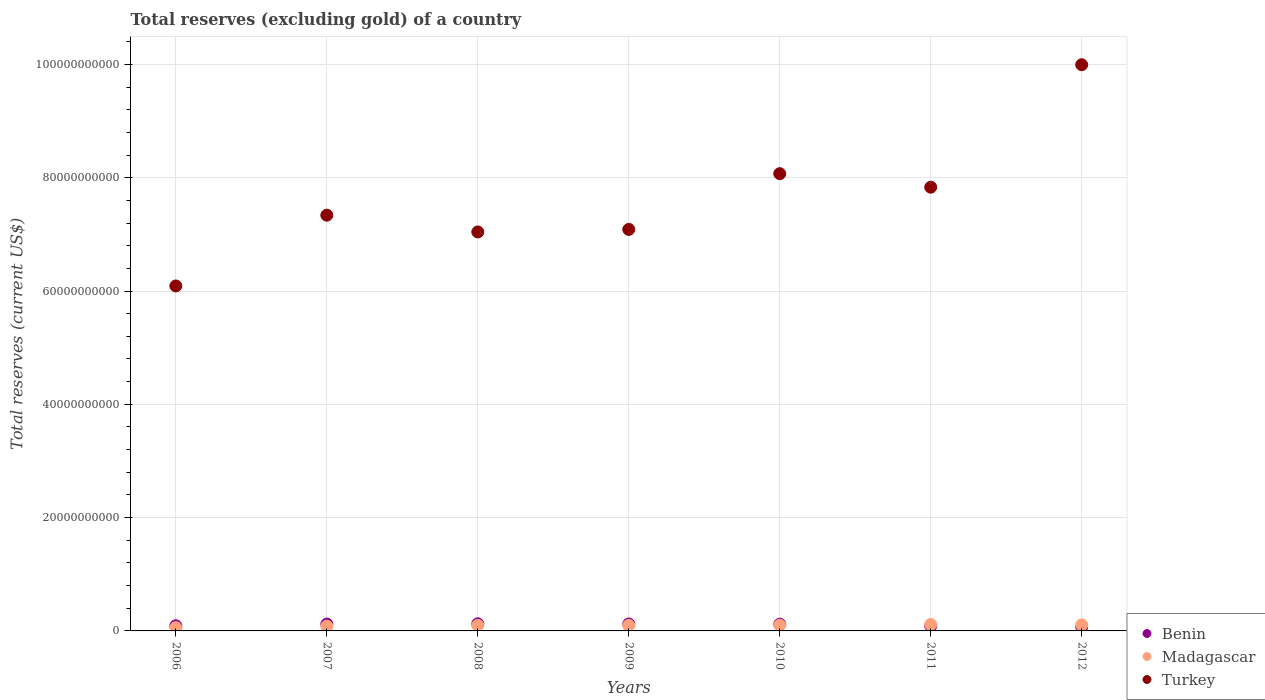How many different coloured dotlines are there?
Offer a terse response. 3. Is the number of dotlines equal to the number of legend labels?
Offer a very short reply. Yes. What is the total reserves (excluding gold) in Benin in 2006?
Provide a succinct answer. 9.12e+08. Across all years, what is the maximum total reserves (excluding gold) in Madagascar?
Ensure brevity in your answer.  1.13e+09. Across all years, what is the minimum total reserves (excluding gold) in Benin?
Offer a very short reply. 7.13e+08. In which year was the total reserves (excluding gold) in Benin maximum?
Ensure brevity in your answer.  2008. What is the total total reserves (excluding gold) in Turkey in the graph?
Provide a succinct answer. 5.35e+11. What is the difference between the total reserves (excluding gold) in Turkey in 2006 and that in 2011?
Ensure brevity in your answer.  -1.74e+1. What is the difference between the total reserves (excluding gold) in Benin in 2007 and the total reserves (excluding gold) in Turkey in 2010?
Offer a very short reply. -7.95e+1. What is the average total reserves (excluding gold) in Benin per year?
Offer a terse response. 1.06e+09. In the year 2012, what is the difference between the total reserves (excluding gold) in Madagascar and total reserves (excluding gold) in Benin?
Ensure brevity in your answer.  3.40e+08. What is the ratio of the total reserves (excluding gold) in Benin in 2007 to that in 2008?
Provide a short and direct response. 0.96. Is the total reserves (excluding gold) in Turkey in 2009 less than that in 2010?
Your response must be concise. Yes. What is the difference between the highest and the second highest total reserves (excluding gold) in Benin?
Give a very brief answer. 3.35e+07. What is the difference between the highest and the lowest total reserves (excluding gold) in Turkey?
Keep it short and to the point. 3.91e+1. In how many years, is the total reserves (excluding gold) in Turkey greater than the average total reserves (excluding gold) in Turkey taken over all years?
Your answer should be compact. 3. Is the sum of the total reserves (excluding gold) in Madagascar in 2011 and 2012 greater than the maximum total reserves (excluding gold) in Benin across all years?
Keep it short and to the point. Yes. Is it the case that in every year, the sum of the total reserves (excluding gold) in Benin and total reserves (excluding gold) in Madagascar  is greater than the total reserves (excluding gold) in Turkey?
Keep it short and to the point. No. Does the total reserves (excluding gold) in Madagascar monotonically increase over the years?
Provide a short and direct response. No. Is the total reserves (excluding gold) in Turkey strictly less than the total reserves (excluding gold) in Madagascar over the years?
Offer a terse response. No. How many dotlines are there?
Offer a terse response. 3. Does the graph contain any zero values?
Offer a very short reply. No. Does the graph contain grids?
Provide a short and direct response. Yes. How are the legend labels stacked?
Make the answer very short. Vertical. What is the title of the graph?
Keep it short and to the point. Total reserves (excluding gold) of a country. What is the label or title of the X-axis?
Provide a short and direct response. Years. What is the label or title of the Y-axis?
Your response must be concise. Total reserves (current US$). What is the Total reserves (current US$) of Benin in 2006?
Make the answer very short. 9.12e+08. What is the Total reserves (current US$) of Madagascar in 2006?
Provide a short and direct response. 5.83e+08. What is the Total reserves (current US$) in Turkey in 2006?
Provide a short and direct response. 6.09e+1. What is the Total reserves (current US$) of Benin in 2007?
Your answer should be very brief. 1.21e+09. What is the Total reserves (current US$) of Madagascar in 2007?
Keep it short and to the point. 8.47e+08. What is the Total reserves (current US$) in Turkey in 2007?
Your response must be concise. 7.34e+1. What is the Total reserves (current US$) of Benin in 2008?
Ensure brevity in your answer.  1.26e+09. What is the Total reserves (current US$) in Madagascar in 2008?
Your response must be concise. 9.82e+08. What is the Total reserves (current US$) in Turkey in 2008?
Your response must be concise. 7.04e+1. What is the Total reserves (current US$) of Benin in 2009?
Make the answer very short. 1.23e+09. What is the Total reserves (current US$) in Madagascar in 2009?
Offer a terse response. 9.82e+08. What is the Total reserves (current US$) of Turkey in 2009?
Provide a short and direct response. 7.09e+1. What is the Total reserves (current US$) in Benin in 2010?
Offer a terse response. 1.20e+09. What is the Total reserves (current US$) in Madagascar in 2010?
Your response must be concise. 1.02e+09. What is the Total reserves (current US$) in Turkey in 2010?
Your response must be concise. 8.07e+1. What is the Total reserves (current US$) of Benin in 2011?
Your response must be concise. 8.87e+08. What is the Total reserves (current US$) in Madagascar in 2011?
Your answer should be very brief. 1.13e+09. What is the Total reserves (current US$) in Turkey in 2011?
Provide a short and direct response. 7.83e+1. What is the Total reserves (current US$) in Benin in 2012?
Provide a short and direct response. 7.13e+08. What is the Total reserves (current US$) in Madagascar in 2012?
Provide a short and direct response. 1.05e+09. What is the Total reserves (current US$) in Turkey in 2012?
Offer a very short reply. 9.99e+1. Across all years, what is the maximum Total reserves (current US$) in Benin?
Provide a succinct answer. 1.26e+09. Across all years, what is the maximum Total reserves (current US$) in Madagascar?
Give a very brief answer. 1.13e+09. Across all years, what is the maximum Total reserves (current US$) in Turkey?
Offer a terse response. 9.99e+1. Across all years, what is the minimum Total reserves (current US$) in Benin?
Your response must be concise. 7.13e+08. Across all years, what is the minimum Total reserves (current US$) in Madagascar?
Your answer should be very brief. 5.83e+08. Across all years, what is the minimum Total reserves (current US$) in Turkey?
Your answer should be very brief. 6.09e+1. What is the total Total reserves (current US$) of Benin in the graph?
Your answer should be very brief. 7.41e+09. What is the total Total reserves (current US$) of Madagascar in the graph?
Give a very brief answer. 6.60e+09. What is the total Total reserves (current US$) of Turkey in the graph?
Give a very brief answer. 5.35e+11. What is the difference between the Total reserves (current US$) of Benin in 2006 and that in 2007?
Your answer should be compact. -2.97e+08. What is the difference between the Total reserves (current US$) in Madagascar in 2006 and that in 2007?
Provide a succinct answer. -2.63e+08. What is the difference between the Total reserves (current US$) of Turkey in 2006 and that in 2007?
Make the answer very short. -1.25e+1. What is the difference between the Total reserves (current US$) of Benin in 2006 and that in 2008?
Offer a terse response. -3.51e+08. What is the difference between the Total reserves (current US$) of Madagascar in 2006 and that in 2008?
Ensure brevity in your answer.  -3.99e+08. What is the difference between the Total reserves (current US$) of Turkey in 2006 and that in 2008?
Offer a terse response. -9.54e+09. What is the difference between the Total reserves (current US$) of Benin in 2006 and that in 2009?
Provide a succinct answer. -3.18e+08. What is the difference between the Total reserves (current US$) in Madagascar in 2006 and that in 2009?
Ensure brevity in your answer.  -3.99e+08. What is the difference between the Total reserves (current US$) of Turkey in 2006 and that in 2009?
Your answer should be compact. -9.98e+09. What is the difference between the Total reserves (current US$) in Benin in 2006 and that in 2010?
Your response must be concise. -2.88e+08. What is the difference between the Total reserves (current US$) of Madagascar in 2006 and that in 2010?
Keep it short and to the point. -4.40e+08. What is the difference between the Total reserves (current US$) of Turkey in 2006 and that in 2010?
Give a very brief answer. -1.98e+1. What is the difference between the Total reserves (current US$) in Benin in 2006 and that in 2011?
Your answer should be very brief. 2.48e+07. What is the difference between the Total reserves (current US$) in Madagascar in 2006 and that in 2011?
Your answer should be very brief. -5.51e+08. What is the difference between the Total reserves (current US$) of Turkey in 2006 and that in 2011?
Provide a succinct answer. -1.74e+1. What is the difference between the Total reserves (current US$) in Benin in 2006 and that in 2012?
Offer a very short reply. 1.99e+08. What is the difference between the Total reserves (current US$) of Madagascar in 2006 and that in 2012?
Your answer should be compact. -4.70e+08. What is the difference between the Total reserves (current US$) of Turkey in 2006 and that in 2012?
Ensure brevity in your answer.  -3.91e+1. What is the difference between the Total reserves (current US$) in Benin in 2007 and that in 2008?
Your answer should be very brief. -5.41e+07. What is the difference between the Total reserves (current US$) of Madagascar in 2007 and that in 2008?
Your answer should be compact. -1.36e+08. What is the difference between the Total reserves (current US$) in Turkey in 2007 and that in 2008?
Your answer should be compact. 2.96e+09. What is the difference between the Total reserves (current US$) in Benin in 2007 and that in 2009?
Provide a short and direct response. -2.06e+07. What is the difference between the Total reserves (current US$) of Madagascar in 2007 and that in 2009?
Provide a short and direct response. -1.35e+08. What is the difference between the Total reserves (current US$) of Turkey in 2007 and that in 2009?
Provide a succinct answer. 2.51e+09. What is the difference between the Total reserves (current US$) of Benin in 2007 and that in 2010?
Give a very brief answer. 9.15e+06. What is the difference between the Total reserves (current US$) of Madagascar in 2007 and that in 2010?
Ensure brevity in your answer.  -1.76e+08. What is the difference between the Total reserves (current US$) of Turkey in 2007 and that in 2010?
Give a very brief answer. -7.33e+09. What is the difference between the Total reserves (current US$) in Benin in 2007 and that in 2011?
Give a very brief answer. 3.22e+08. What is the difference between the Total reserves (current US$) in Madagascar in 2007 and that in 2011?
Provide a succinct answer. -2.88e+08. What is the difference between the Total reserves (current US$) in Turkey in 2007 and that in 2011?
Ensure brevity in your answer.  -4.94e+09. What is the difference between the Total reserves (current US$) of Benin in 2007 and that in 2012?
Offer a very short reply. 4.96e+08. What is the difference between the Total reserves (current US$) of Madagascar in 2007 and that in 2012?
Give a very brief answer. -2.06e+08. What is the difference between the Total reserves (current US$) in Turkey in 2007 and that in 2012?
Ensure brevity in your answer.  -2.66e+1. What is the difference between the Total reserves (current US$) of Benin in 2008 and that in 2009?
Offer a terse response. 3.35e+07. What is the difference between the Total reserves (current US$) in Madagascar in 2008 and that in 2009?
Make the answer very short. 2.28e+05. What is the difference between the Total reserves (current US$) of Turkey in 2008 and that in 2009?
Offer a very short reply. -4.46e+08. What is the difference between the Total reserves (current US$) in Benin in 2008 and that in 2010?
Provide a succinct answer. 6.33e+07. What is the difference between the Total reserves (current US$) in Madagascar in 2008 and that in 2010?
Your response must be concise. -4.07e+07. What is the difference between the Total reserves (current US$) in Turkey in 2008 and that in 2010?
Make the answer very short. -1.03e+1. What is the difference between the Total reserves (current US$) in Benin in 2008 and that in 2011?
Keep it short and to the point. 3.76e+08. What is the difference between the Total reserves (current US$) of Madagascar in 2008 and that in 2011?
Your response must be concise. -1.52e+08. What is the difference between the Total reserves (current US$) of Turkey in 2008 and that in 2011?
Give a very brief answer. -7.89e+09. What is the difference between the Total reserves (current US$) of Benin in 2008 and that in 2012?
Keep it short and to the point. 5.51e+08. What is the difference between the Total reserves (current US$) in Madagascar in 2008 and that in 2012?
Provide a short and direct response. -7.05e+07. What is the difference between the Total reserves (current US$) of Turkey in 2008 and that in 2012?
Your answer should be compact. -2.95e+1. What is the difference between the Total reserves (current US$) in Benin in 2009 and that in 2010?
Offer a terse response. 2.98e+07. What is the difference between the Total reserves (current US$) of Madagascar in 2009 and that in 2010?
Give a very brief answer. -4.09e+07. What is the difference between the Total reserves (current US$) of Turkey in 2009 and that in 2010?
Make the answer very short. -9.84e+09. What is the difference between the Total reserves (current US$) of Benin in 2009 and that in 2011?
Your answer should be very brief. 3.42e+08. What is the difference between the Total reserves (current US$) of Madagascar in 2009 and that in 2011?
Provide a succinct answer. -1.52e+08. What is the difference between the Total reserves (current US$) of Turkey in 2009 and that in 2011?
Make the answer very short. -7.45e+09. What is the difference between the Total reserves (current US$) in Benin in 2009 and that in 2012?
Give a very brief answer. 5.17e+08. What is the difference between the Total reserves (current US$) in Madagascar in 2009 and that in 2012?
Your response must be concise. -7.07e+07. What is the difference between the Total reserves (current US$) in Turkey in 2009 and that in 2012?
Your answer should be very brief. -2.91e+1. What is the difference between the Total reserves (current US$) in Benin in 2010 and that in 2011?
Ensure brevity in your answer.  3.13e+08. What is the difference between the Total reserves (current US$) in Madagascar in 2010 and that in 2011?
Offer a very short reply. -1.12e+08. What is the difference between the Total reserves (current US$) in Turkey in 2010 and that in 2011?
Your response must be concise. 2.39e+09. What is the difference between the Total reserves (current US$) in Benin in 2010 and that in 2012?
Your answer should be very brief. 4.87e+08. What is the difference between the Total reserves (current US$) of Madagascar in 2010 and that in 2012?
Make the answer very short. -2.98e+07. What is the difference between the Total reserves (current US$) of Turkey in 2010 and that in 2012?
Make the answer very short. -1.92e+1. What is the difference between the Total reserves (current US$) of Benin in 2011 and that in 2012?
Your answer should be compact. 1.75e+08. What is the difference between the Total reserves (current US$) of Madagascar in 2011 and that in 2012?
Your answer should be compact. 8.17e+07. What is the difference between the Total reserves (current US$) in Turkey in 2011 and that in 2012?
Ensure brevity in your answer.  -2.16e+1. What is the difference between the Total reserves (current US$) of Benin in 2006 and the Total reserves (current US$) of Madagascar in 2007?
Your response must be concise. 6.55e+07. What is the difference between the Total reserves (current US$) of Benin in 2006 and the Total reserves (current US$) of Turkey in 2007?
Your response must be concise. -7.25e+1. What is the difference between the Total reserves (current US$) of Madagascar in 2006 and the Total reserves (current US$) of Turkey in 2007?
Ensure brevity in your answer.  -7.28e+1. What is the difference between the Total reserves (current US$) in Benin in 2006 and the Total reserves (current US$) in Madagascar in 2008?
Provide a succinct answer. -7.01e+07. What is the difference between the Total reserves (current US$) of Benin in 2006 and the Total reserves (current US$) of Turkey in 2008?
Offer a very short reply. -6.95e+1. What is the difference between the Total reserves (current US$) of Madagascar in 2006 and the Total reserves (current US$) of Turkey in 2008?
Your answer should be very brief. -6.98e+1. What is the difference between the Total reserves (current US$) in Benin in 2006 and the Total reserves (current US$) in Madagascar in 2009?
Your answer should be very brief. -6.99e+07. What is the difference between the Total reserves (current US$) in Benin in 2006 and the Total reserves (current US$) in Turkey in 2009?
Give a very brief answer. -7.00e+1. What is the difference between the Total reserves (current US$) of Madagascar in 2006 and the Total reserves (current US$) of Turkey in 2009?
Offer a very short reply. -7.03e+1. What is the difference between the Total reserves (current US$) of Benin in 2006 and the Total reserves (current US$) of Madagascar in 2010?
Keep it short and to the point. -1.11e+08. What is the difference between the Total reserves (current US$) of Benin in 2006 and the Total reserves (current US$) of Turkey in 2010?
Offer a terse response. -7.98e+1. What is the difference between the Total reserves (current US$) in Madagascar in 2006 and the Total reserves (current US$) in Turkey in 2010?
Offer a very short reply. -8.01e+1. What is the difference between the Total reserves (current US$) in Benin in 2006 and the Total reserves (current US$) in Madagascar in 2011?
Give a very brief answer. -2.22e+08. What is the difference between the Total reserves (current US$) in Benin in 2006 and the Total reserves (current US$) in Turkey in 2011?
Ensure brevity in your answer.  -7.74e+1. What is the difference between the Total reserves (current US$) in Madagascar in 2006 and the Total reserves (current US$) in Turkey in 2011?
Give a very brief answer. -7.77e+1. What is the difference between the Total reserves (current US$) in Benin in 2006 and the Total reserves (current US$) in Madagascar in 2012?
Your answer should be very brief. -1.41e+08. What is the difference between the Total reserves (current US$) in Benin in 2006 and the Total reserves (current US$) in Turkey in 2012?
Your answer should be very brief. -9.90e+1. What is the difference between the Total reserves (current US$) in Madagascar in 2006 and the Total reserves (current US$) in Turkey in 2012?
Ensure brevity in your answer.  -9.94e+1. What is the difference between the Total reserves (current US$) of Benin in 2007 and the Total reserves (current US$) of Madagascar in 2008?
Your answer should be very brief. 2.27e+08. What is the difference between the Total reserves (current US$) in Benin in 2007 and the Total reserves (current US$) in Turkey in 2008?
Your answer should be compact. -6.92e+1. What is the difference between the Total reserves (current US$) in Madagascar in 2007 and the Total reserves (current US$) in Turkey in 2008?
Make the answer very short. -6.96e+1. What is the difference between the Total reserves (current US$) in Benin in 2007 and the Total reserves (current US$) in Madagascar in 2009?
Offer a very short reply. 2.27e+08. What is the difference between the Total reserves (current US$) of Benin in 2007 and the Total reserves (current US$) of Turkey in 2009?
Make the answer very short. -6.97e+1. What is the difference between the Total reserves (current US$) in Madagascar in 2007 and the Total reserves (current US$) in Turkey in 2009?
Give a very brief answer. -7.00e+1. What is the difference between the Total reserves (current US$) of Benin in 2007 and the Total reserves (current US$) of Madagascar in 2010?
Your response must be concise. 1.86e+08. What is the difference between the Total reserves (current US$) in Benin in 2007 and the Total reserves (current US$) in Turkey in 2010?
Keep it short and to the point. -7.95e+1. What is the difference between the Total reserves (current US$) of Madagascar in 2007 and the Total reserves (current US$) of Turkey in 2010?
Your response must be concise. -7.99e+1. What is the difference between the Total reserves (current US$) of Benin in 2007 and the Total reserves (current US$) of Madagascar in 2011?
Provide a succinct answer. 7.46e+07. What is the difference between the Total reserves (current US$) of Benin in 2007 and the Total reserves (current US$) of Turkey in 2011?
Your answer should be very brief. -7.71e+1. What is the difference between the Total reserves (current US$) in Madagascar in 2007 and the Total reserves (current US$) in Turkey in 2011?
Make the answer very short. -7.75e+1. What is the difference between the Total reserves (current US$) in Benin in 2007 and the Total reserves (current US$) in Madagascar in 2012?
Keep it short and to the point. 1.56e+08. What is the difference between the Total reserves (current US$) of Benin in 2007 and the Total reserves (current US$) of Turkey in 2012?
Your response must be concise. -9.87e+1. What is the difference between the Total reserves (current US$) in Madagascar in 2007 and the Total reserves (current US$) in Turkey in 2012?
Offer a very short reply. -9.91e+1. What is the difference between the Total reserves (current US$) of Benin in 2008 and the Total reserves (current US$) of Madagascar in 2009?
Offer a terse response. 2.81e+08. What is the difference between the Total reserves (current US$) in Benin in 2008 and the Total reserves (current US$) in Turkey in 2009?
Offer a terse response. -6.96e+1. What is the difference between the Total reserves (current US$) of Madagascar in 2008 and the Total reserves (current US$) of Turkey in 2009?
Give a very brief answer. -6.99e+1. What is the difference between the Total reserves (current US$) in Benin in 2008 and the Total reserves (current US$) in Madagascar in 2010?
Keep it short and to the point. 2.40e+08. What is the difference between the Total reserves (current US$) of Benin in 2008 and the Total reserves (current US$) of Turkey in 2010?
Provide a succinct answer. -7.94e+1. What is the difference between the Total reserves (current US$) in Madagascar in 2008 and the Total reserves (current US$) in Turkey in 2010?
Your answer should be compact. -7.97e+1. What is the difference between the Total reserves (current US$) of Benin in 2008 and the Total reserves (current US$) of Madagascar in 2011?
Provide a short and direct response. 1.29e+08. What is the difference between the Total reserves (current US$) of Benin in 2008 and the Total reserves (current US$) of Turkey in 2011?
Make the answer very short. -7.71e+1. What is the difference between the Total reserves (current US$) in Madagascar in 2008 and the Total reserves (current US$) in Turkey in 2011?
Your answer should be compact. -7.73e+1. What is the difference between the Total reserves (current US$) in Benin in 2008 and the Total reserves (current US$) in Madagascar in 2012?
Provide a short and direct response. 2.11e+08. What is the difference between the Total reserves (current US$) of Benin in 2008 and the Total reserves (current US$) of Turkey in 2012?
Offer a terse response. -9.87e+1. What is the difference between the Total reserves (current US$) of Madagascar in 2008 and the Total reserves (current US$) of Turkey in 2012?
Provide a succinct answer. -9.90e+1. What is the difference between the Total reserves (current US$) in Benin in 2009 and the Total reserves (current US$) in Madagascar in 2010?
Your response must be concise. 2.07e+08. What is the difference between the Total reserves (current US$) in Benin in 2009 and the Total reserves (current US$) in Turkey in 2010?
Offer a very short reply. -7.95e+1. What is the difference between the Total reserves (current US$) in Madagascar in 2009 and the Total reserves (current US$) in Turkey in 2010?
Provide a short and direct response. -7.97e+1. What is the difference between the Total reserves (current US$) in Benin in 2009 and the Total reserves (current US$) in Madagascar in 2011?
Make the answer very short. 9.53e+07. What is the difference between the Total reserves (current US$) in Benin in 2009 and the Total reserves (current US$) in Turkey in 2011?
Give a very brief answer. -7.71e+1. What is the difference between the Total reserves (current US$) in Madagascar in 2009 and the Total reserves (current US$) in Turkey in 2011?
Keep it short and to the point. -7.73e+1. What is the difference between the Total reserves (current US$) in Benin in 2009 and the Total reserves (current US$) in Madagascar in 2012?
Your answer should be very brief. 1.77e+08. What is the difference between the Total reserves (current US$) in Benin in 2009 and the Total reserves (current US$) in Turkey in 2012?
Your answer should be very brief. -9.87e+1. What is the difference between the Total reserves (current US$) in Madagascar in 2009 and the Total reserves (current US$) in Turkey in 2012?
Your answer should be very brief. -9.90e+1. What is the difference between the Total reserves (current US$) in Benin in 2010 and the Total reserves (current US$) in Madagascar in 2011?
Your answer should be very brief. 6.55e+07. What is the difference between the Total reserves (current US$) in Benin in 2010 and the Total reserves (current US$) in Turkey in 2011?
Provide a short and direct response. -7.71e+1. What is the difference between the Total reserves (current US$) in Madagascar in 2010 and the Total reserves (current US$) in Turkey in 2011?
Ensure brevity in your answer.  -7.73e+1. What is the difference between the Total reserves (current US$) in Benin in 2010 and the Total reserves (current US$) in Madagascar in 2012?
Offer a very short reply. 1.47e+08. What is the difference between the Total reserves (current US$) of Benin in 2010 and the Total reserves (current US$) of Turkey in 2012?
Make the answer very short. -9.87e+1. What is the difference between the Total reserves (current US$) of Madagascar in 2010 and the Total reserves (current US$) of Turkey in 2012?
Offer a terse response. -9.89e+1. What is the difference between the Total reserves (current US$) of Benin in 2011 and the Total reserves (current US$) of Madagascar in 2012?
Provide a succinct answer. -1.65e+08. What is the difference between the Total reserves (current US$) of Benin in 2011 and the Total reserves (current US$) of Turkey in 2012?
Provide a short and direct response. -9.91e+1. What is the difference between the Total reserves (current US$) in Madagascar in 2011 and the Total reserves (current US$) in Turkey in 2012?
Ensure brevity in your answer.  -9.88e+1. What is the average Total reserves (current US$) in Benin per year?
Make the answer very short. 1.06e+09. What is the average Total reserves (current US$) in Madagascar per year?
Give a very brief answer. 9.44e+08. What is the average Total reserves (current US$) in Turkey per year?
Ensure brevity in your answer.  7.64e+1. In the year 2006, what is the difference between the Total reserves (current US$) of Benin and Total reserves (current US$) of Madagascar?
Your response must be concise. 3.29e+08. In the year 2006, what is the difference between the Total reserves (current US$) in Benin and Total reserves (current US$) in Turkey?
Keep it short and to the point. -6.00e+1. In the year 2006, what is the difference between the Total reserves (current US$) of Madagascar and Total reserves (current US$) of Turkey?
Offer a terse response. -6.03e+1. In the year 2007, what is the difference between the Total reserves (current US$) in Benin and Total reserves (current US$) in Madagascar?
Offer a terse response. 3.63e+08. In the year 2007, what is the difference between the Total reserves (current US$) of Benin and Total reserves (current US$) of Turkey?
Provide a succinct answer. -7.22e+1. In the year 2007, what is the difference between the Total reserves (current US$) in Madagascar and Total reserves (current US$) in Turkey?
Provide a succinct answer. -7.25e+1. In the year 2008, what is the difference between the Total reserves (current US$) in Benin and Total reserves (current US$) in Madagascar?
Keep it short and to the point. 2.81e+08. In the year 2008, what is the difference between the Total reserves (current US$) of Benin and Total reserves (current US$) of Turkey?
Ensure brevity in your answer.  -6.92e+1. In the year 2008, what is the difference between the Total reserves (current US$) of Madagascar and Total reserves (current US$) of Turkey?
Make the answer very short. -6.94e+1. In the year 2009, what is the difference between the Total reserves (current US$) in Benin and Total reserves (current US$) in Madagascar?
Keep it short and to the point. 2.48e+08. In the year 2009, what is the difference between the Total reserves (current US$) of Benin and Total reserves (current US$) of Turkey?
Your response must be concise. -6.96e+1. In the year 2009, what is the difference between the Total reserves (current US$) of Madagascar and Total reserves (current US$) of Turkey?
Ensure brevity in your answer.  -6.99e+1. In the year 2010, what is the difference between the Total reserves (current US$) in Benin and Total reserves (current US$) in Madagascar?
Give a very brief answer. 1.77e+08. In the year 2010, what is the difference between the Total reserves (current US$) of Benin and Total reserves (current US$) of Turkey?
Ensure brevity in your answer.  -7.95e+1. In the year 2010, what is the difference between the Total reserves (current US$) in Madagascar and Total reserves (current US$) in Turkey?
Provide a succinct answer. -7.97e+1. In the year 2011, what is the difference between the Total reserves (current US$) of Benin and Total reserves (current US$) of Madagascar?
Provide a short and direct response. -2.47e+08. In the year 2011, what is the difference between the Total reserves (current US$) in Benin and Total reserves (current US$) in Turkey?
Offer a terse response. -7.74e+1. In the year 2011, what is the difference between the Total reserves (current US$) in Madagascar and Total reserves (current US$) in Turkey?
Keep it short and to the point. -7.72e+1. In the year 2012, what is the difference between the Total reserves (current US$) in Benin and Total reserves (current US$) in Madagascar?
Offer a terse response. -3.40e+08. In the year 2012, what is the difference between the Total reserves (current US$) in Benin and Total reserves (current US$) in Turkey?
Make the answer very short. -9.92e+1. In the year 2012, what is the difference between the Total reserves (current US$) of Madagascar and Total reserves (current US$) of Turkey?
Your response must be concise. -9.89e+1. What is the ratio of the Total reserves (current US$) of Benin in 2006 to that in 2007?
Keep it short and to the point. 0.75. What is the ratio of the Total reserves (current US$) of Madagascar in 2006 to that in 2007?
Provide a short and direct response. 0.69. What is the ratio of the Total reserves (current US$) of Turkey in 2006 to that in 2007?
Provide a succinct answer. 0.83. What is the ratio of the Total reserves (current US$) of Benin in 2006 to that in 2008?
Offer a very short reply. 0.72. What is the ratio of the Total reserves (current US$) of Madagascar in 2006 to that in 2008?
Ensure brevity in your answer.  0.59. What is the ratio of the Total reserves (current US$) in Turkey in 2006 to that in 2008?
Ensure brevity in your answer.  0.86. What is the ratio of the Total reserves (current US$) in Benin in 2006 to that in 2009?
Your response must be concise. 0.74. What is the ratio of the Total reserves (current US$) of Madagascar in 2006 to that in 2009?
Provide a succinct answer. 0.59. What is the ratio of the Total reserves (current US$) of Turkey in 2006 to that in 2009?
Make the answer very short. 0.86. What is the ratio of the Total reserves (current US$) of Benin in 2006 to that in 2010?
Give a very brief answer. 0.76. What is the ratio of the Total reserves (current US$) of Madagascar in 2006 to that in 2010?
Offer a very short reply. 0.57. What is the ratio of the Total reserves (current US$) of Turkey in 2006 to that in 2010?
Offer a terse response. 0.75. What is the ratio of the Total reserves (current US$) of Benin in 2006 to that in 2011?
Your response must be concise. 1.03. What is the ratio of the Total reserves (current US$) of Madagascar in 2006 to that in 2011?
Your answer should be compact. 0.51. What is the ratio of the Total reserves (current US$) in Turkey in 2006 to that in 2011?
Your answer should be very brief. 0.78. What is the ratio of the Total reserves (current US$) in Benin in 2006 to that in 2012?
Give a very brief answer. 1.28. What is the ratio of the Total reserves (current US$) of Madagascar in 2006 to that in 2012?
Provide a succinct answer. 0.55. What is the ratio of the Total reserves (current US$) in Turkey in 2006 to that in 2012?
Offer a terse response. 0.61. What is the ratio of the Total reserves (current US$) in Benin in 2007 to that in 2008?
Your answer should be compact. 0.96. What is the ratio of the Total reserves (current US$) of Madagascar in 2007 to that in 2008?
Provide a succinct answer. 0.86. What is the ratio of the Total reserves (current US$) of Turkey in 2007 to that in 2008?
Keep it short and to the point. 1.04. What is the ratio of the Total reserves (current US$) of Benin in 2007 to that in 2009?
Ensure brevity in your answer.  0.98. What is the ratio of the Total reserves (current US$) in Madagascar in 2007 to that in 2009?
Offer a terse response. 0.86. What is the ratio of the Total reserves (current US$) of Turkey in 2007 to that in 2009?
Ensure brevity in your answer.  1.04. What is the ratio of the Total reserves (current US$) of Benin in 2007 to that in 2010?
Your answer should be very brief. 1.01. What is the ratio of the Total reserves (current US$) in Madagascar in 2007 to that in 2010?
Give a very brief answer. 0.83. What is the ratio of the Total reserves (current US$) in Turkey in 2007 to that in 2010?
Your response must be concise. 0.91. What is the ratio of the Total reserves (current US$) in Benin in 2007 to that in 2011?
Keep it short and to the point. 1.36. What is the ratio of the Total reserves (current US$) in Madagascar in 2007 to that in 2011?
Your answer should be compact. 0.75. What is the ratio of the Total reserves (current US$) in Turkey in 2007 to that in 2011?
Ensure brevity in your answer.  0.94. What is the ratio of the Total reserves (current US$) in Benin in 2007 to that in 2012?
Your answer should be very brief. 1.7. What is the ratio of the Total reserves (current US$) in Madagascar in 2007 to that in 2012?
Your response must be concise. 0.8. What is the ratio of the Total reserves (current US$) in Turkey in 2007 to that in 2012?
Offer a terse response. 0.73. What is the ratio of the Total reserves (current US$) in Benin in 2008 to that in 2009?
Give a very brief answer. 1.03. What is the ratio of the Total reserves (current US$) in Turkey in 2008 to that in 2009?
Offer a very short reply. 0.99. What is the ratio of the Total reserves (current US$) in Benin in 2008 to that in 2010?
Offer a terse response. 1.05. What is the ratio of the Total reserves (current US$) of Madagascar in 2008 to that in 2010?
Your answer should be very brief. 0.96. What is the ratio of the Total reserves (current US$) in Turkey in 2008 to that in 2010?
Offer a terse response. 0.87. What is the ratio of the Total reserves (current US$) in Benin in 2008 to that in 2011?
Give a very brief answer. 1.42. What is the ratio of the Total reserves (current US$) of Madagascar in 2008 to that in 2011?
Offer a terse response. 0.87. What is the ratio of the Total reserves (current US$) of Turkey in 2008 to that in 2011?
Provide a short and direct response. 0.9. What is the ratio of the Total reserves (current US$) of Benin in 2008 to that in 2012?
Provide a succinct answer. 1.77. What is the ratio of the Total reserves (current US$) of Madagascar in 2008 to that in 2012?
Make the answer very short. 0.93. What is the ratio of the Total reserves (current US$) in Turkey in 2008 to that in 2012?
Your response must be concise. 0.7. What is the ratio of the Total reserves (current US$) in Benin in 2009 to that in 2010?
Your answer should be compact. 1.02. What is the ratio of the Total reserves (current US$) in Turkey in 2009 to that in 2010?
Keep it short and to the point. 0.88. What is the ratio of the Total reserves (current US$) in Benin in 2009 to that in 2011?
Offer a very short reply. 1.39. What is the ratio of the Total reserves (current US$) of Madagascar in 2009 to that in 2011?
Offer a very short reply. 0.87. What is the ratio of the Total reserves (current US$) in Turkey in 2009 to that in 2011?
Your answer should be very brief. 0.9. What is the ratio of the Total reserves (current US$) of Benin in 2009 to that in 2012?
Give a very brief answer. 1.73. What is the ratio of the Total reserves (current US$) of Madagascar in 2009 to that in 2012?
Make the answer very short. 0.93. What is the ratio of the Total reserves (current US$) of Turkey in 2009 to that in 2012?
Provide a succinct answer. 0.71. What is the ratio of the Total reserves (current US$) of Benin in 2010 to that in 2011?
Keep it short and to the point. 1.35. What is the ratio of the Total reserves (current US$) of Madagascar in 2010 to that in 2011?
Ensure brevity in your answer.  0.9. What is the ratio of the Total reserves (current US$) of Turkey in 2010 to that in 2011?
Your answer should be compact. 1.03. What is the ratio of the Total reserves (current US$) in Benin in 2010 to that in 2012?
Keep it short and to the point. 1.68. What is the ratio of the Total reserves (current US$) of Madagascar in 2010 to that in 2012?
Provide a short and direct response. 0.97. What is the ratio of the Total reserves (current US$) in Turkey in 2010 to that in 2012?
Give a very brief answer. 0.81. What is the ratio of the Total reserves (current US$) in Benin in 2011 to that in 2012?
Your response must be concise. 1.24. What is the ratio of the Total reserves (current US$) in Madagascar in 2011 to that in 2012?
Ensure brevity in your answer.  1.08. What is the ratio of the Total reserves (current US$) in Turkey in 2011 to that in 2012?
Your answer should be very brief. 0.78. What is the difference between the highest and the second highest Total reserves (current US$) of Benin?
Your response must be concise. 3.35e+07. What is the difference between the highest and the second highest Total reserves (current US$) in Madagascar?
Offer a very short reply. 8.17e+07. What is the difference between the highest and the second highest Total reserves (current US$) in Turkey?
Make the answer very short. 1.92e+1. What is the difference between the highest and the lowest Total reserves (current US$) of Benin?
Offer a terse response. 5.51e+08. What is the difference between the highest and the lowest Total reserves (current US$) of Madagascar?
Your answer should be very brief. 5.51e+08. What is the difference between the highest and the lowest Total reserves (current US$) in Turkey?
Provide a succinct answer. 3.91e+1. 